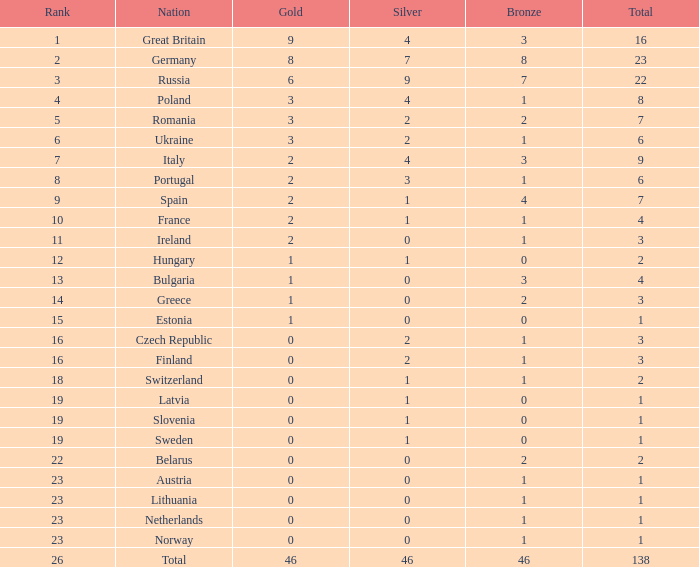What is the mean position when the bronze exceeds 1, and silver is below 0? None. 